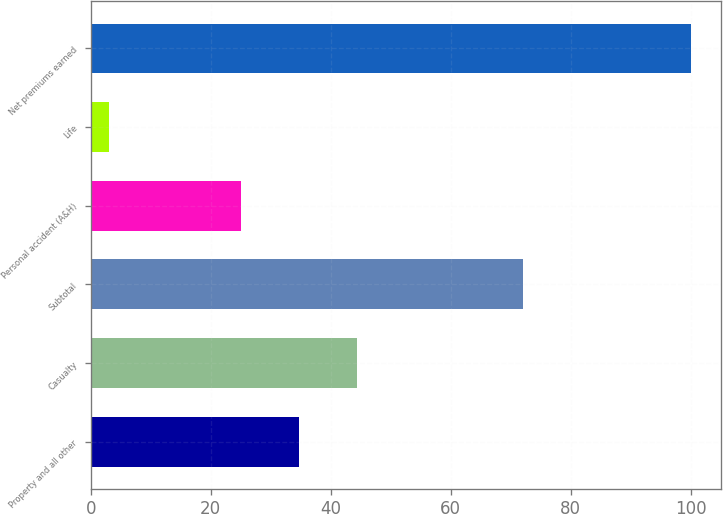Convert chart. <chart><loc_0><loc_0><loc_500><loc_500><bar_chart><fcel>Property and all other<fcel>Casualty<fcel>Subtotal<fcel>Personal accident (A&H)<fcel>Life<fcel>Net premiums earned<nl><fcel>34.7<fcel>44.4<fcel>72<fcel>25<fcel>3<fcel>100<nl></chart> 